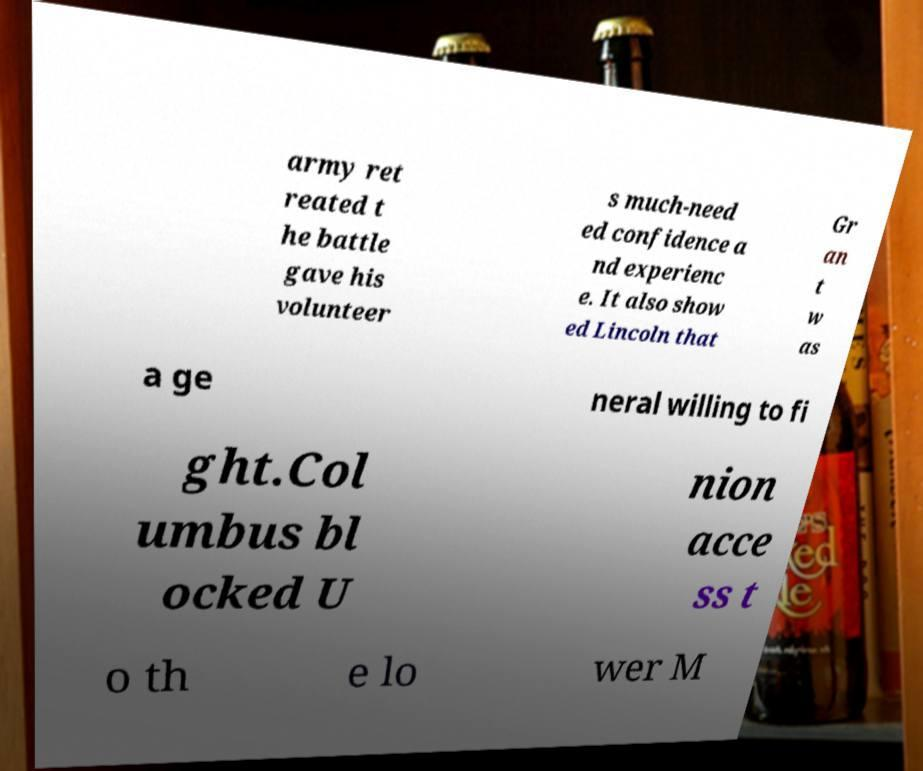There's text embedded in this image that I need extracted. Can you transcribe it verbatim? army ret reated t he battle gave his volunteer s much-need ed confidence a nd experienc e. It also show ed Lincoln that Gr an t w as a ge neral willing to fi ght.Col umbus bl ocked U nion acce ss t o th e lo wer M 